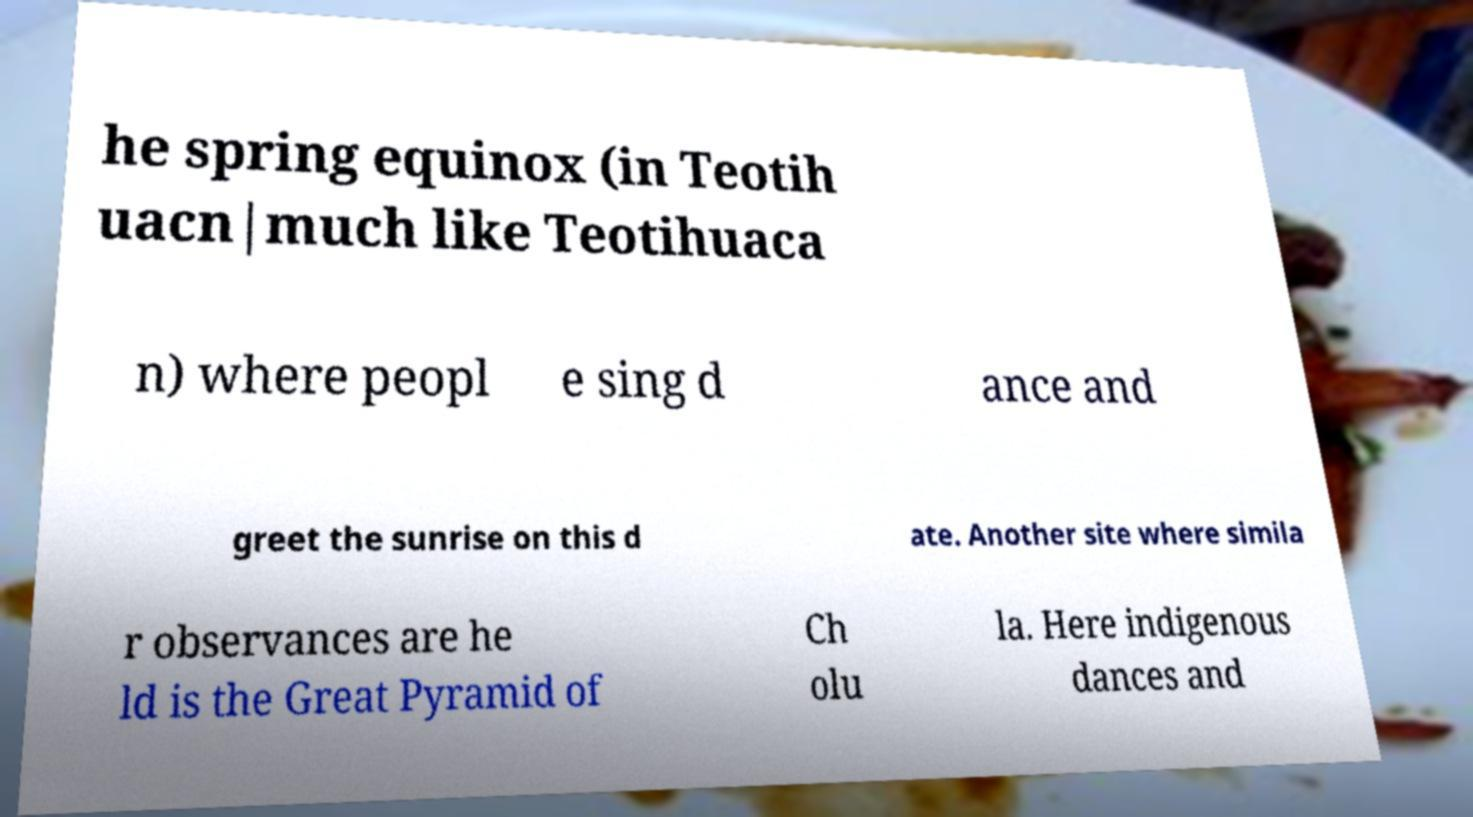Could you extract and type out the text from this image? he spring equinox (in Teotih uacn|much like Teotihuaca n) where peopl e sing d ance and greet the sunrise on this d ate. Another site where simila r observances are he ld is the Great Pyramid of Ch olu la. Here indigenous dances and 